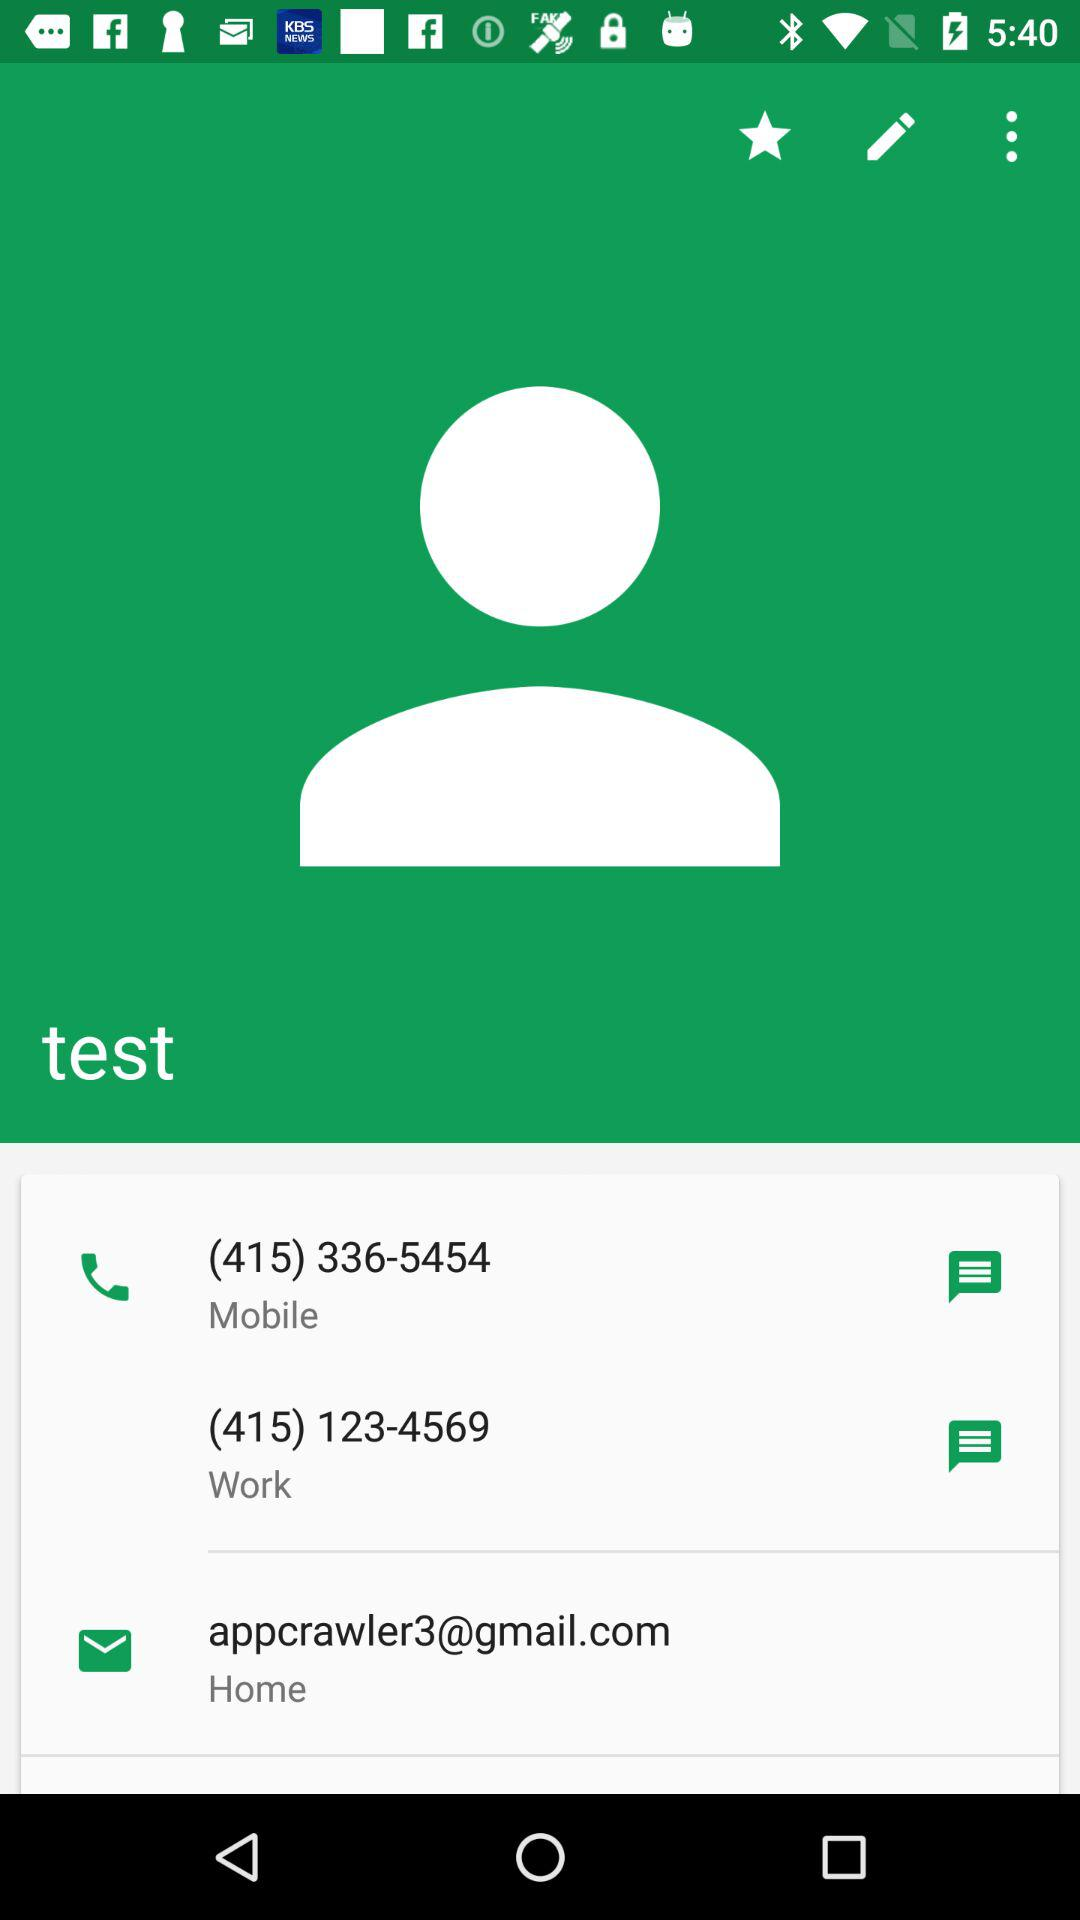What is the Gmail address? The Gmail address is appcrawler3@gmail.com. 